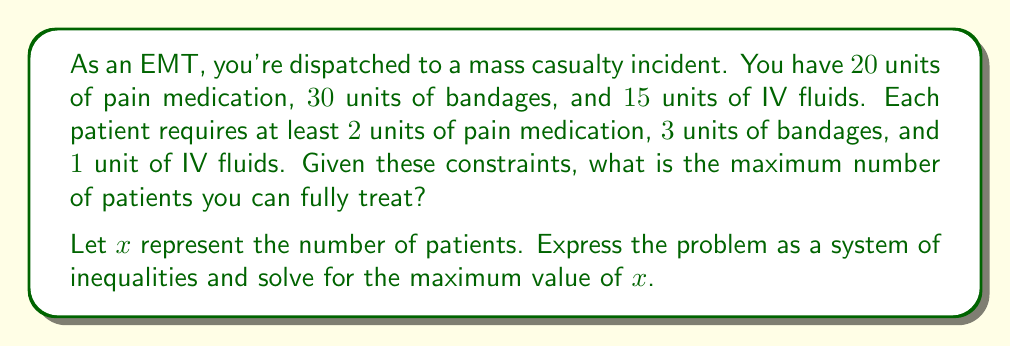What is the answer to this math problem? Let's approach this step-by-step:

1) First, we need to set up our inequalities based on the given information:

   For pain medication: $2x \leq 20$
   For bandages: $3x \leq 30$
   For IV fluids: $x \leq 15$

2) We also know that $x$ must be a non-negative integer:

   $x \geq 0$ and $x$ is an integer

3) Now, let's solve each inequality for $x$:

   From $2x \leq 20$, we get $x \leq 10$
   From $3x \leq 30$, we get $x \leq 10$
   From $x \leq 15$, we already have $x \leq 15$

4) The most restrictive conditions are $x \leq 10$ (from both pain medication and bandages).

5) Therefore, the maximum value of $x$ that satisfies all conditions is 10.

6) We need to check if this integer solution satisfies all original inequalities:

   For pain medication: $2(10) = 20 \leq 20$ (Satisfies)
   For bandages: $3(10) = 30 \leq 30$ (Satisfies)
   For IV fluids: $10 \leq 15$ (Satisfies)

Thus, the maximum number of patients that can be fully treated is 10.
Answer: The maximum number of patients that can be fully treated is 10. 